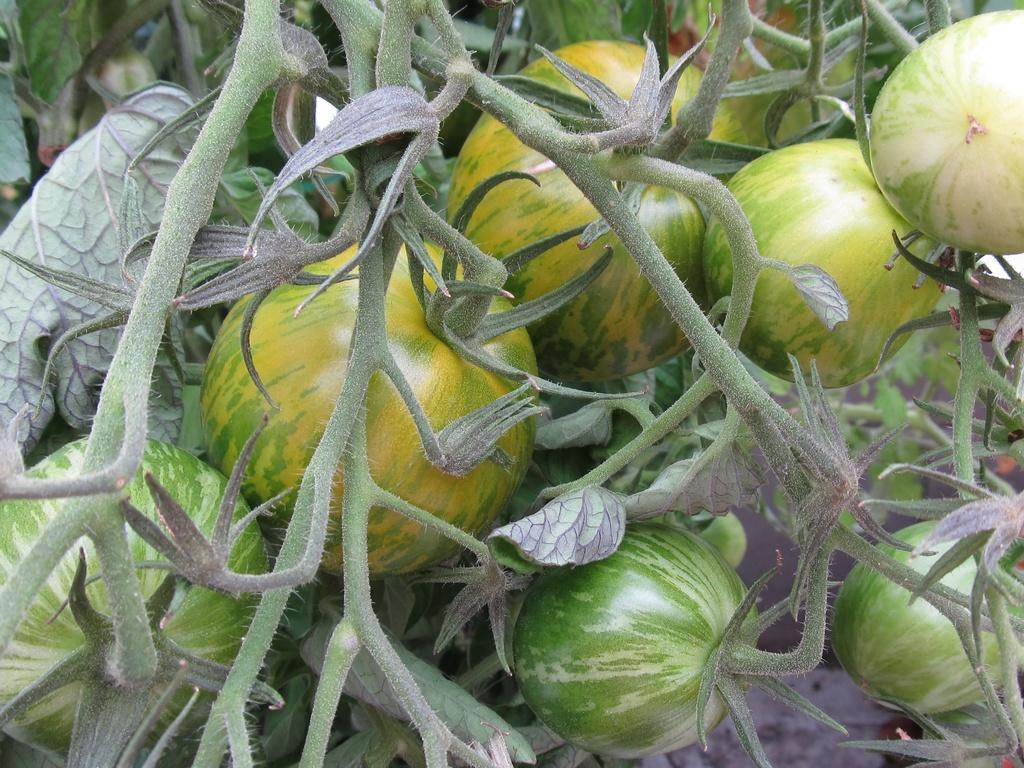What type of food is visible in the image? There are vegetables of a plant in the image. Can you describe the vegetables in more detail? Unfortunately, the specific type of vegetables cannot be determined from the provided fact. What type of cheese is present in the image? There is no cheese present in the image; it features vegetables of a plant. What kind of toys can be seen in the image? There are no toys present in the image; it features vegetables of a plant. 